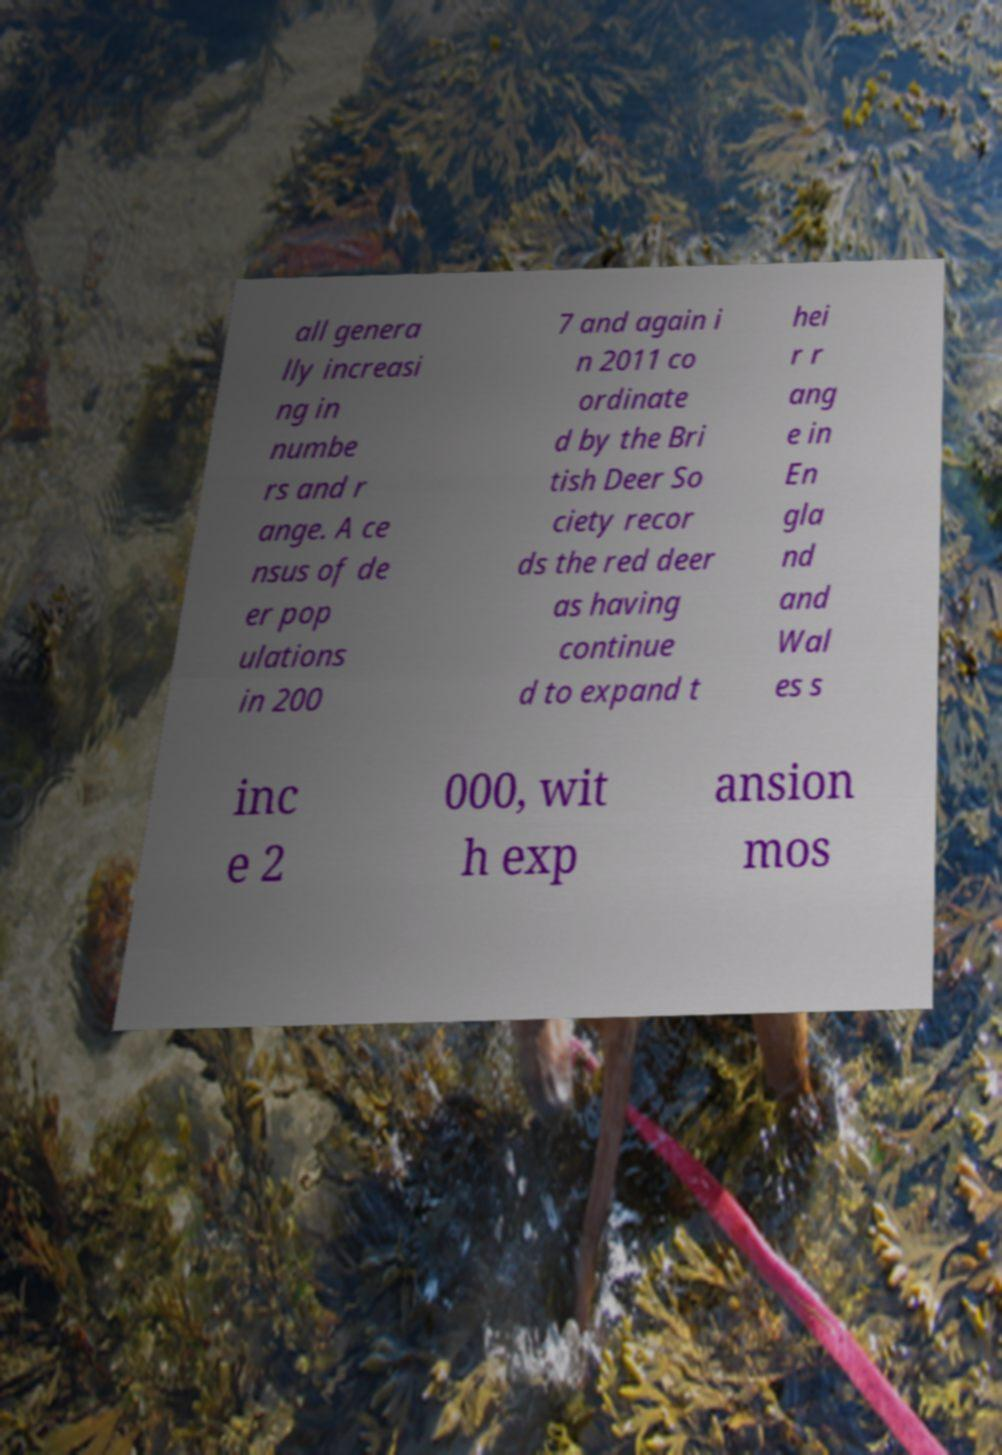What messages or text are displayed in this image? I need them in a readable, typed format. all genera lly increasi ng in numbe rs and r ange. A ce nsus of de er pop ulations in 200 7 and again i n 2011 co ordinate d by the Bri tish Deer So ciety recor ds the red deer as having continue d to expand t hei r r ang e in En gla nd and Wal es s inc e 2 000, wit h exp ansion mos 